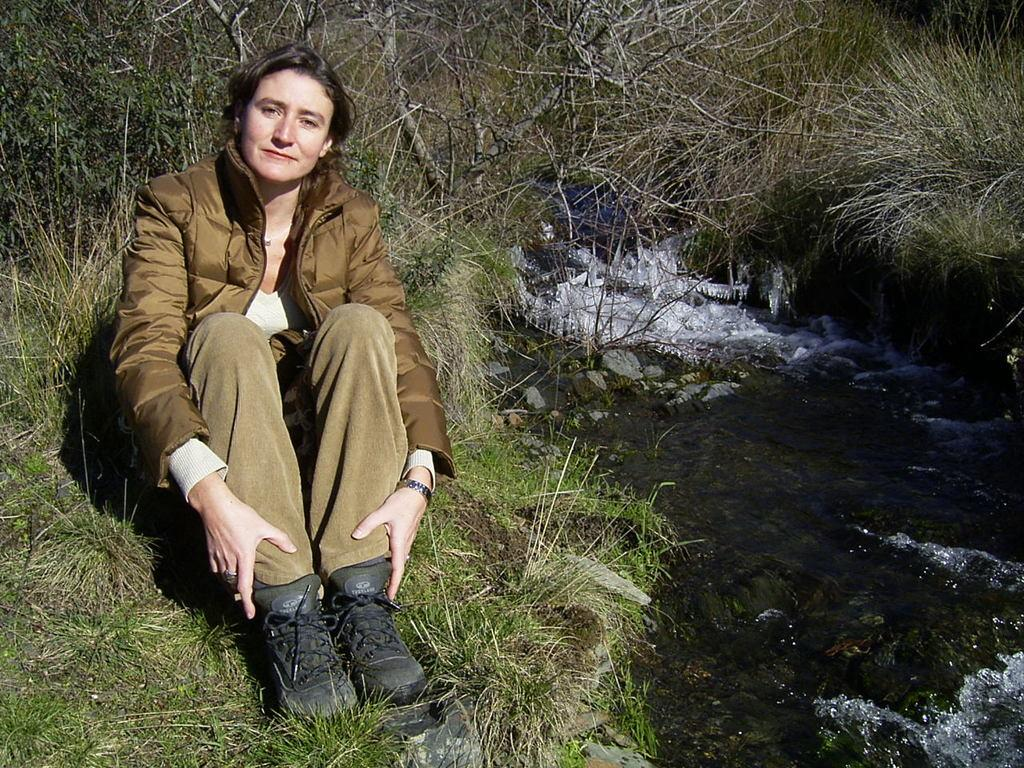Who is the main subject in the image? There is a lady in the image. Where is the lady located in the image? The lady is on the left side of the image. What type of environment is the lady in? The lady is on a grassland. What can be seen on the opposite side of the lady in the image? There is water on the right side of the image. What type of example can be seen in the image? There is no example present in the image; it features a lady on a grassland with water on the right side. How many cats are visible in the image? There are no cats present in the image. 